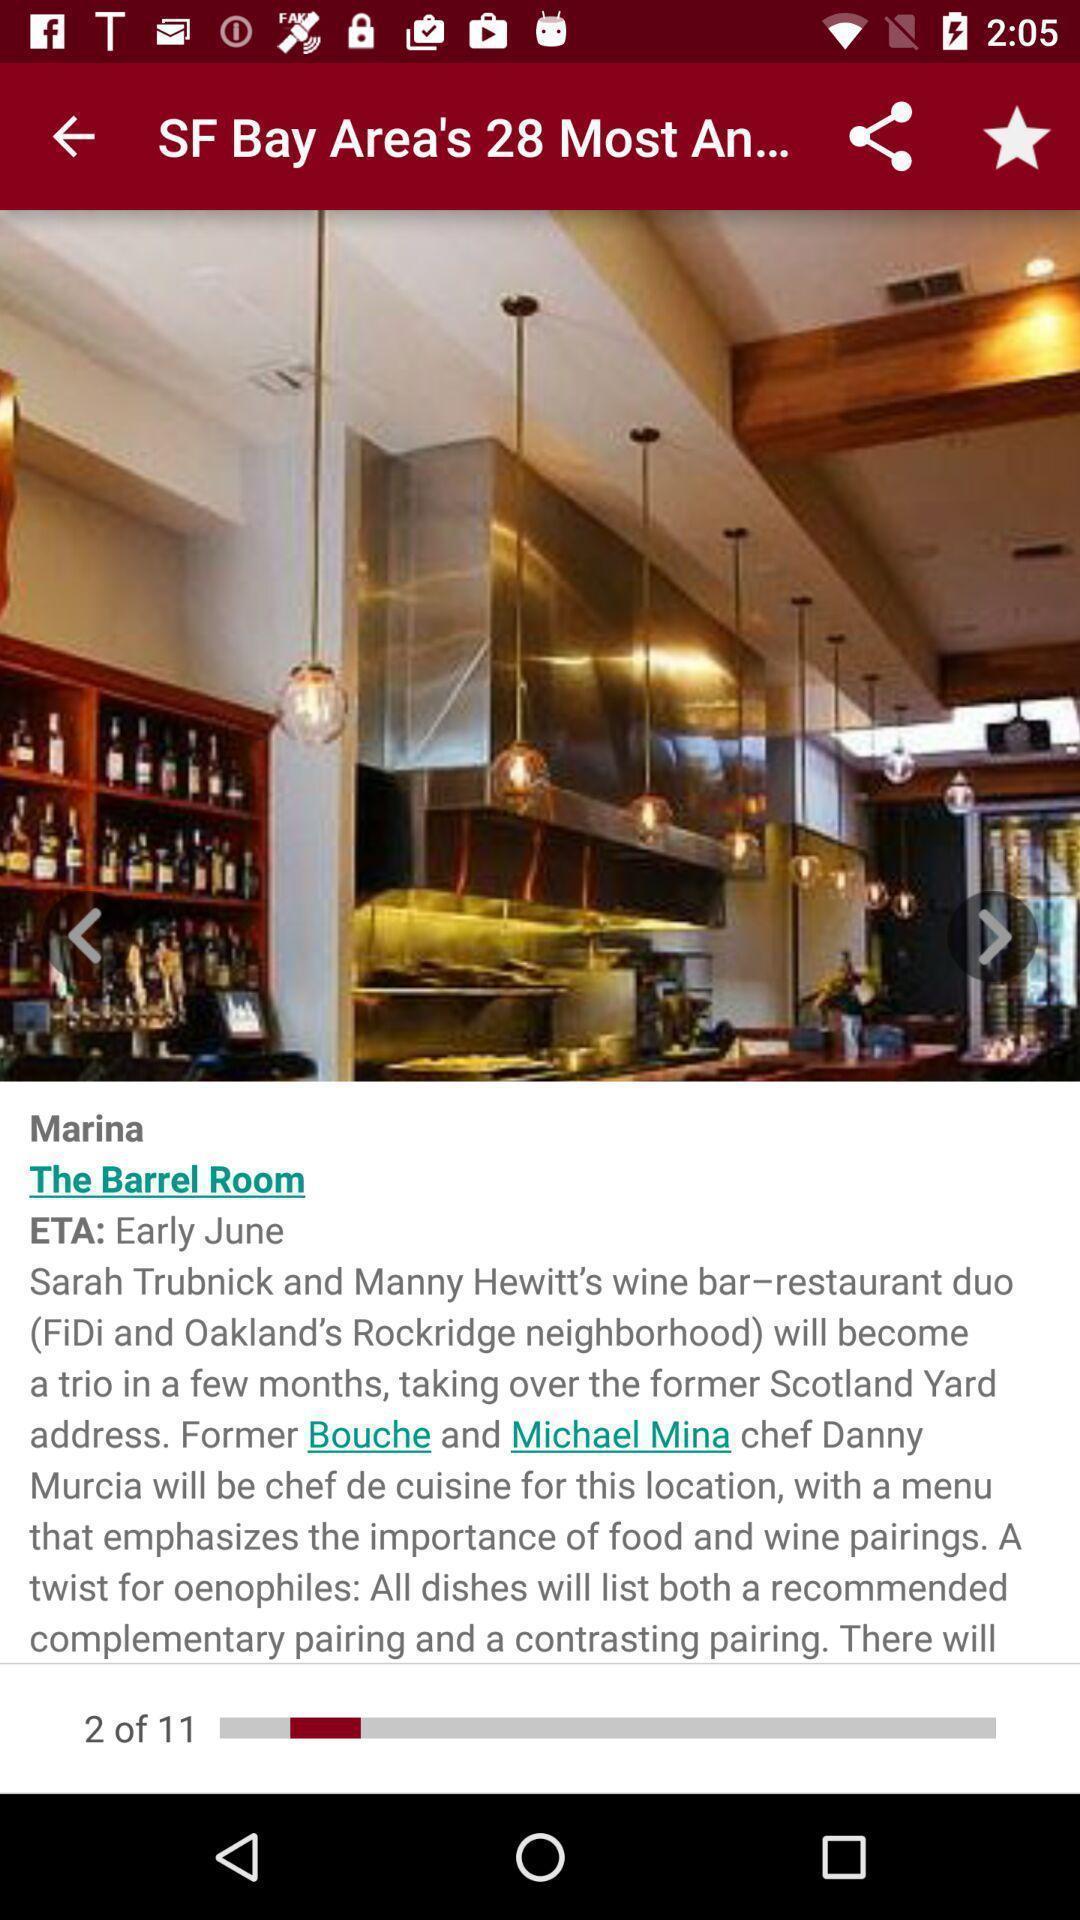What is the overall content of this screenshot? Page with the location of a barrel room. 